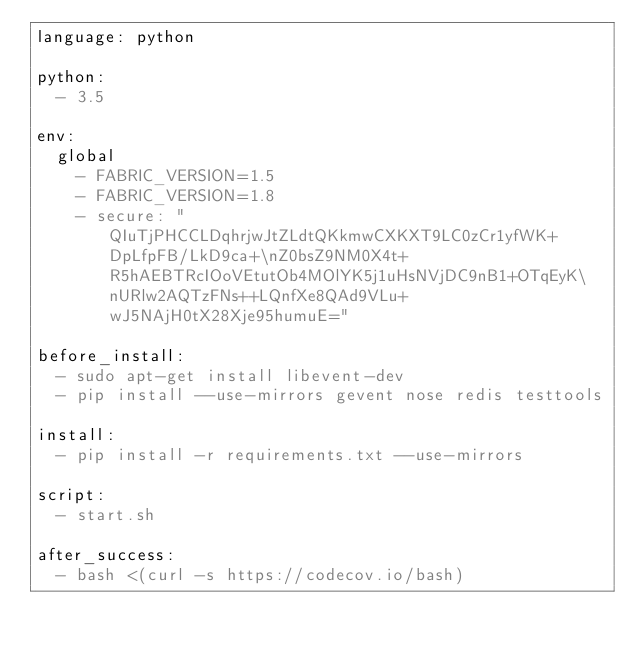Convert code to text. <code><loc_0><loc_0><loc_500><loc_500><_YAML_>language: python

python:
  - 3.5

env:
  global
    - FABRIC_VERSION=1.5
    - FABRIC_VERSION=1.8
    - secure: "QIuTjPHCCLDqhrjwJtZLdtQKkmwCXKXT9LC0zCr1yfWK+DpLfpFB/LkD9ca+\nZ0bsZ9NM0X4t+R5hAEBTRcIOoVEtutOb4MOlYK5j1uHsNVjDC9nB1+OTqEyK\nURlw2AQTzFNs++LQnfXe8QAd9VLu+wJ5NAjH0tX28Xje95humuE="

before_install:
  - sudo apt-get install libevent-dev
  - pip install --use-mirrors gevent nose redis testtools

install:
  - pip install -r requirements.txt --use-mirrors

script:
  - start.sh

after_success:
  - bash <(curl -s https://codecov.io/bash)</code> 